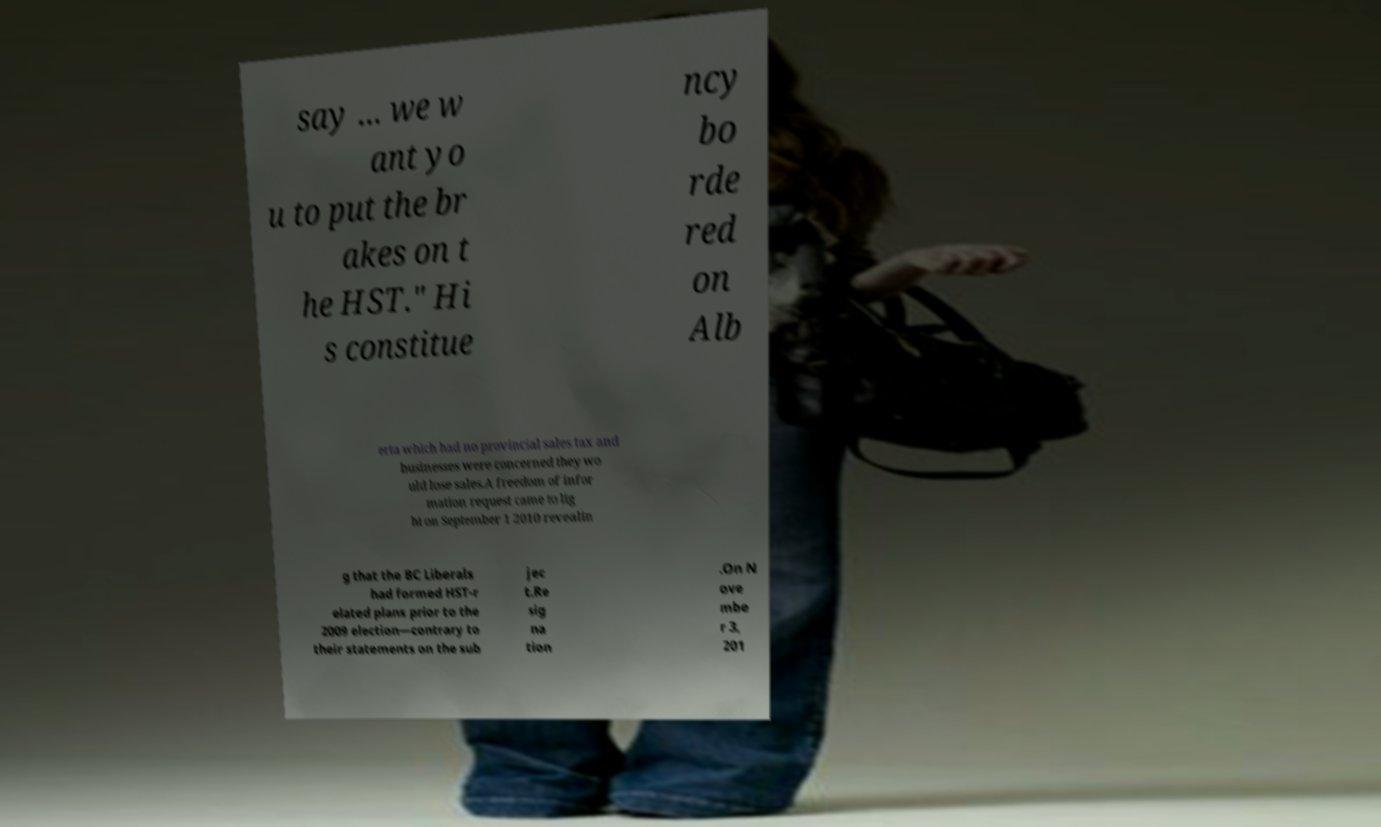Can you read and provide the text displayed in the image?This photo seems to have some interesting text. Can you extract and type it out for me? say ... we w ant yo u to put the br akes on t he HST." Hi s constitue ncy bo rde red on Alb erta which had no provincial sales tax and businesses were concerned they wo uld lose sales.A freedom of infor mation request came to lig ht on September 1 2010 revealin g that the BC Liberals had formed HST-r elated plans prior to the 2009 election—contrary to their statements on the sub jec t.Re sig na tion .On N ove mbe r 3, 201 